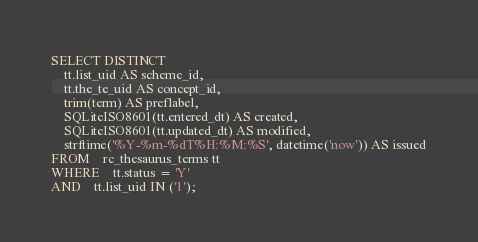<code> <loc_0><loc_0><loc_500><loc_500><_SQL_>SELECT DISTINCT
	tt.list_uid AS scheme_id,
	tt.the_te_uid AS concept_id,
	trim(term) AS preflabel,
	SQLiteISO8601(tt.entered_dt) AS created,
	SQLiteISO8601(tt.updated_dt) AS modified,
	strftime('%Y-%m-%dT%H:%M:%S', datetime('now')) AS issued
FROM 	rc_thesaurus_terms tt
WHERE 	tt.status = 'Y' 
AND	tt.list_uid IN ('1');</code> 